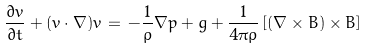<formula> <loc_0><loc_0><loc_500><loc_500>\frac { \partial { v } } { \partial t } + ( { v } \cdot \nabla ) { v } \, = \, - \frac { 1 } { \rho } \nabla p + { g } + \frac { 1 } { 4 \pi \rho } \left [ ( \nabla \times { B } ) \times { B } \right ]</formula> 